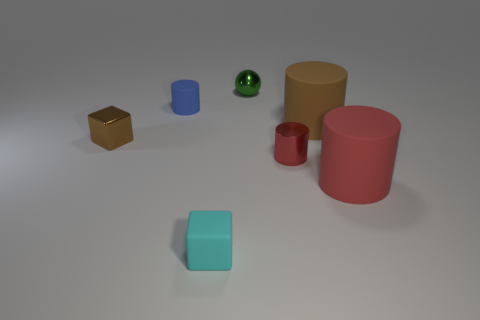Add 1 large blue metallic balls. How many objects exist? 8 Subtract all spheres. How many objects are left? 6 Subtract all small gray cylinders. Subtract all cyan matte things. How many objects are left? 6 Add 2 brown objects. How many brown objects are left? 4 Add 6 tiny red rubber cylinders. How many tiny red rubber cylinders exist? 6 Subtract 1 brown blocks. How many objects are left? 6 